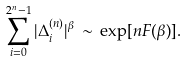<formula> <loc_0><loc_0><loc_500><loc_500>\sum _ { i = 0 } ^ { 2 ^ { n } - 1 } | \Delta _ { i } ^ { ( n ) } | ^ { \beta } \, \sim \, \exp [ n F ( \beta ) ] .</formula> 